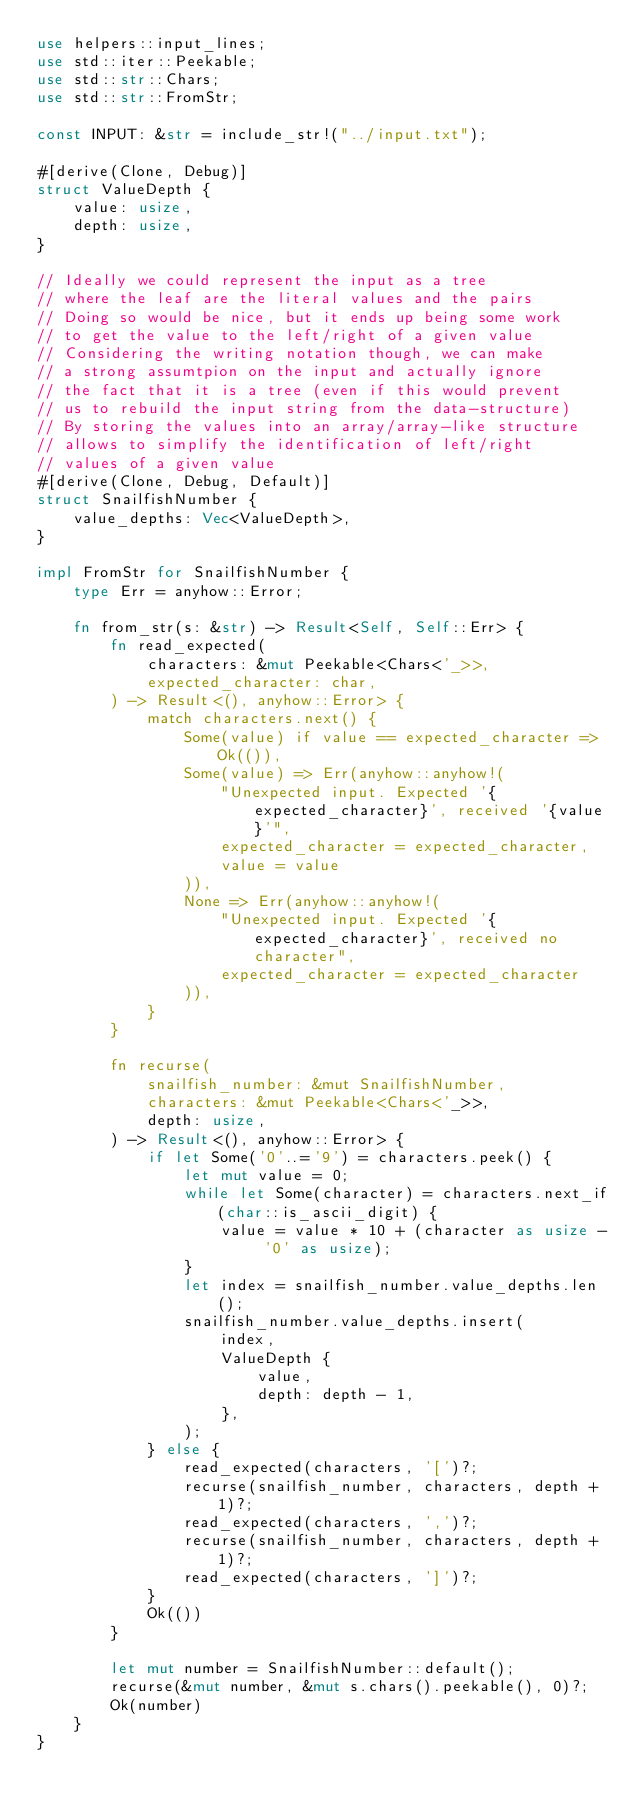Convert code to text. <code><loc_0><loc_0><loc_500><loc_500><_Rust_>use helpers::input_lines;
use std::iter::Peekable;
use std::str::Chars;
use std::str::FromStr;

const INPUT: &str = include_str!("../input.txt");

#[derive(Clone, Debug)]
struct ValueDepth {
    value: usize,
    depth: usize,
}

// Ideally we could represent the input as a tree
// where the leaf are the literal values and the pairs
// Doing so would be nice, but it ends up being some work
// to get the value to the left/right of a given value
// Considering the writing notation though, we can make
// a strong assumtpion on the input and actually ignore
// the fact that it is a tree (even if this would prevent
// us to rebuild the input string from the data-structure)
// By storing the values into an array/array-like structure
// allows to simplify the identification of left/right
// values of a given value
#[derive(Clone, Debug, Default)]
struct SnailfishNumber {
    value_depths: Vec<ValueDepth>,
}

impl FromStr for SnailfishNumber {
    type Err = anyhow::Error;

    fn from_str(s: &str) -> Result<Self, Self::Err> {
        fn read_expected(
            characters: &mut Peekable<Chars<'_>>,
            expected_character: char,
        ) -> Result<(), anyhow::Error> {
            match characters.next() {
                Some(value) if value == expected_character => Ok(()),
                Some(value) => Err(anyhow::anyhow!(
                    "Unexpected input. Expected '{expected_character}', received '{value}'",
                    expected_character = expected_character,
                    value = value
                )),
                None => Err(anyhow::anyhow!(
                    "Unexpected input. Expected '{expected_character}', received no character",
                    expected_character = expected_character
                )),
            }
        }

        fn recurse(
            snailfish_number: &mut SnailfishNumber,
            characters: &mut Peekable<Chars<'_>>,
            depth: usize,
        ) -> Result<(), anyhow::Error> {
            if let Some('0'..='9') = characters.peek() {
                let mut value = 0;
                while let Some(character) = characters.next_if(char::is_ascii_digit) {
                    value = value * 10 + (character as usize - '0' as usize);
                }
                let index = snailfish_number.value_depths.len();
                snailfish_number.value_depths.insert(
                    index,
                    ValueDepth {
                        value,
                        depth: depth - 1,
                    },
                );
            } else {
                read_expected(characters, '[')?;
                recurse(snailfish_number, characters, depth + 1)?;
                read_expected(characters, ',')?;
                recurse(snailfish_number, characters, depth + 1)?;
                read_expected(characters, ']')?;
            }
            Ok(())
        }

        let mut number = SnailfishNumber::default();
        recurse(&mut number, &mut s.chars().peekable(), 0)?;
        Ok(number)
    }
}
</code> 